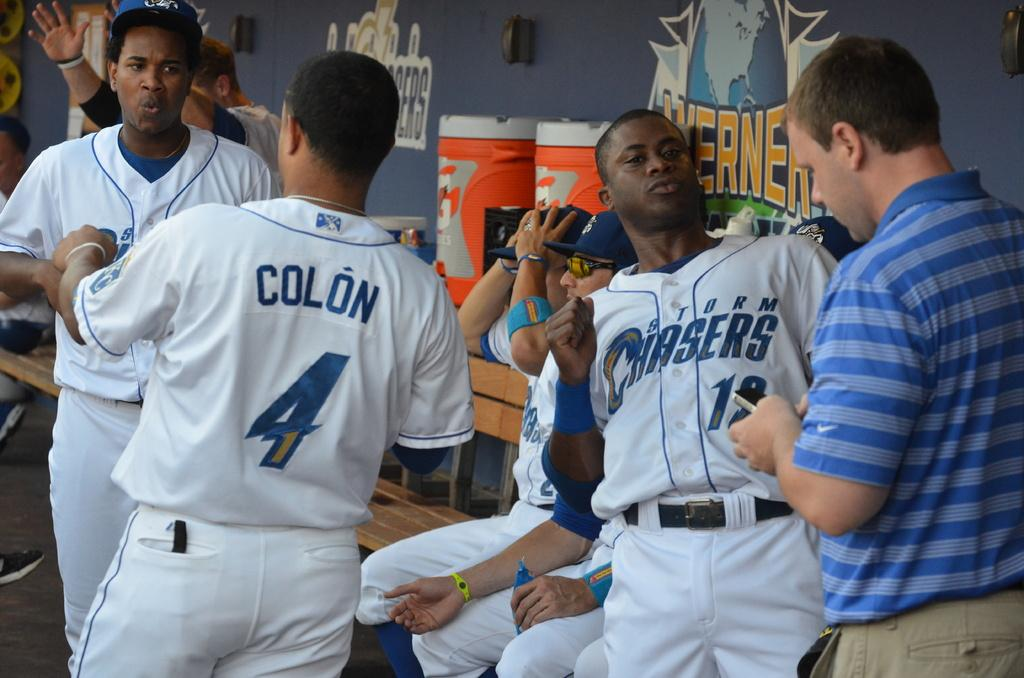<image>
Provide a brief description of the given image. a group of players with one wearing a Chasers outfit 